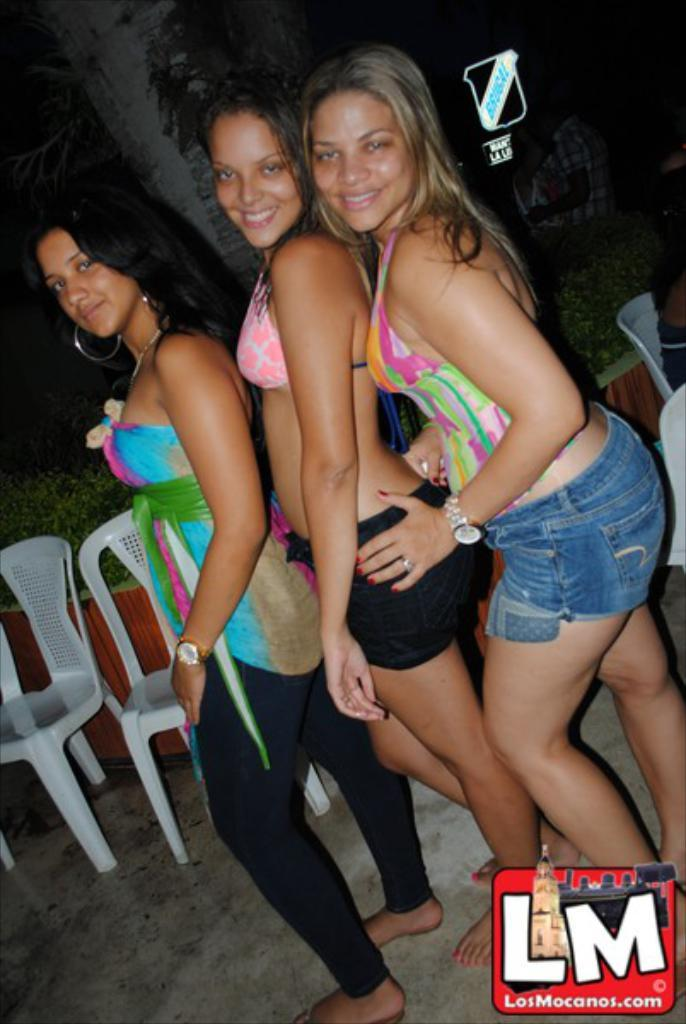How many women are present in the image? There are three women standing in the image. What objects are in the image that might be used for sitting? There are chairs in the image. What type of natural element can be seen in the background of the image? There is a tree visible at the back side of the image. What type of tin can be seen in the hands of the women in the image? There is no tin present in the image, and the women are not holding anything. What type of operation is being performed by the women in the image? There is no operation being performed by the women in the image; they are simply standing. 